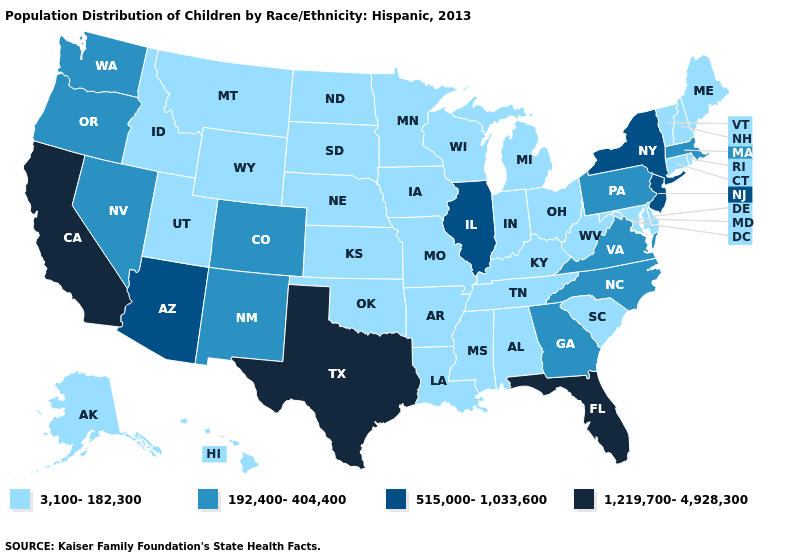Does New Jersey have the same value as Wisconsin?
Give a very brief answer. No. Name the states that have a value in the range 192,400-404,400?
Concise answer only. Colorado, Georgia, Massachusetts, Nevada, New Mexico, North Carolina, Oregon, Pennsylvania, Virginia, Washington. Name the states that have a value in the range 1,219,700-4,928,300?
Concise answer only. California, Florida, Texas. What is the value of Arizona?
Short answer required. 515,000-1,033,600. Name the states that have a value in the range 3,100-182,300?
Keep it brief. Alabama, Alaska, Arkansas, Connecticut, Delaware, Hawaii, Idaho, Indiana, Iowa, Kansas, Kentucky, Louisiana, Maine, Maryland, Michigan, Minnesota, Mississippi, Missouri, Montana, Nebraska, New Hampshire, North Dakota, Ohio, Oklahoma, Rhode Island, South Carolina, South Dakota, Tennessee, Utah, Vermont, West Virginia, Wisconsin, Wyoming. Which states have the highest value in the USA?
Short answer required. California, Florida, Texas. Name the states that have a value in the range 515,000-1,033,600?
Give a very brief answer. Arizona, Illinois, New Jersey, New York. What is the value of South Dakota?
Be succinct. 3,100-182,300. What is the lowest value in the MidWest?
Answer briefly. 3,100-182,300. What is the value of Alaska?
Answer briefly. 3,100-182,300. How many symbols are there in the legend?
Keep it brief. 4. What is the highest value in the Northeast ?
Give a very brief answer. 515,000-1,033,600. Name the states that have a value in the range 515,000-1,033,600?
Give a very brief answer. Arizona, Illinois, New Jersey, New York. Name the states that have a value in the range 1,219,700-4,928,300?
Short answer required. California, Florida, Texas. What is the value of Louisiana?
Keep it brief. 3,100-182,300. 